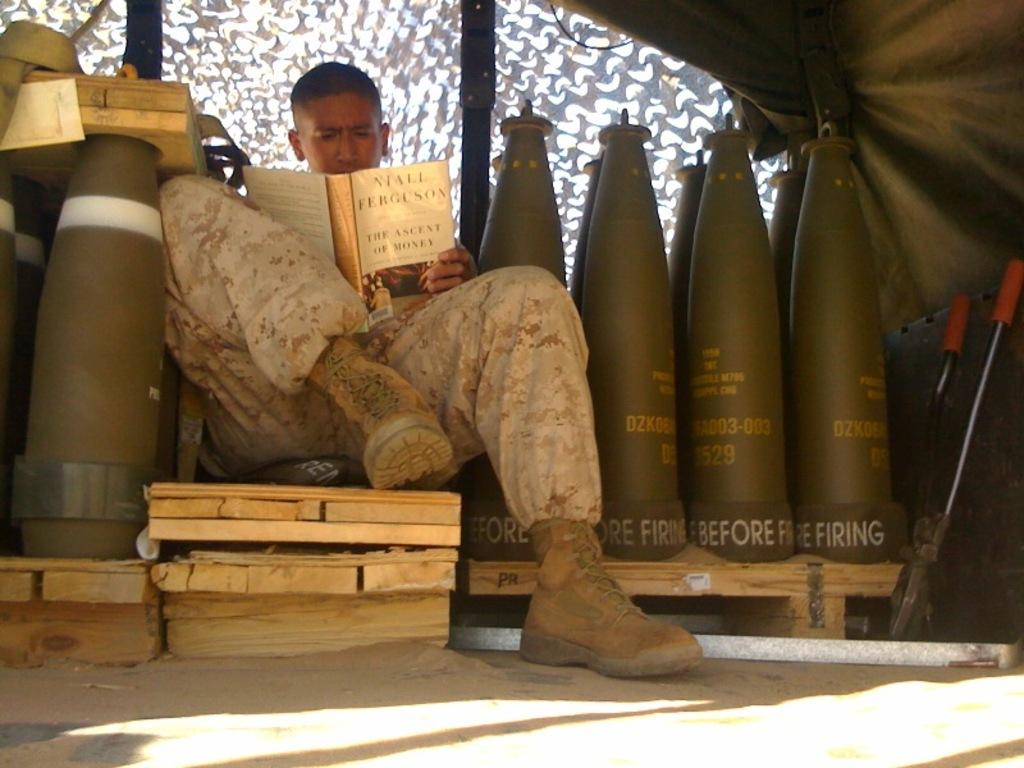What is the man in the image doing? The man is seated and reading a book in the image. What else can be seen in the image besides the man? There are warheads, a tent, and wood visible in the image. What type of boats can be seen in the image? There are no boats present in the image. Where can the man purchase gold in the image? There is no store or gold present in the image. 